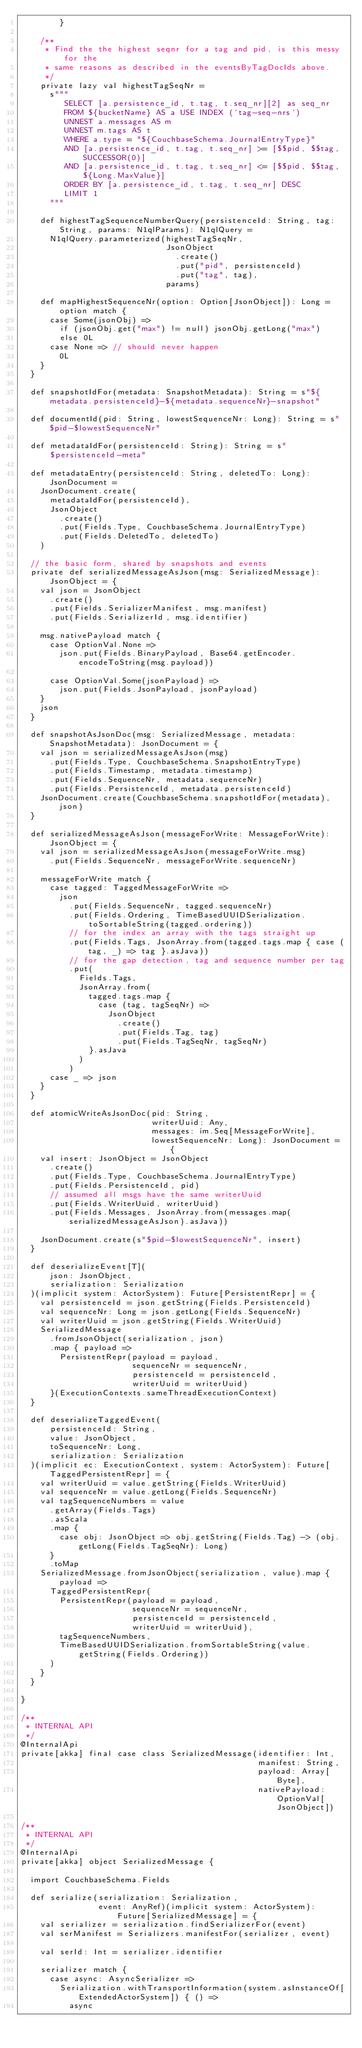<code> <loc_0><loc_0><loc_500><loc_500><_Scala_>        }

    /**
     * Find the the highest seqnr for a tag and pid, is this messy for the
     * same reasons as described in the eventsByTagDocIds above.
     */
    private lazy val highestTagSeqNr =
      s"""
         SELECT [a.persistence_id, t.tag, t.seq_nr][2] as seq_nr
         FROM ${bucketName} AS a USE INDEX (`tag-seq-nrs`)
         UNNEST a.messages AS m
         UNNEST m.tags AS t
         WHERE a.type = "${CouchbaseSchema.JournalEntryType}"
         AND [a.persistence_id, t.tag, t.seq_nr] >= [$$pid, $$tag, SUCCESSOR(0)]
         AND [a.persistence_id, t.tag, t.seq_nr] <= [$$pid, $$tag, ${Long.MaxValue}]
         ORDER BY [a.persistence_id, t.tag, t.seq_nr] DESC
         LIMIT 1
      """

    def highestTagSequenceNumberQuery(persistenceId: String, tag: String, params: N1qlParams): N1qlQuery =
      N1qlQuery.parameterized(highestTagSeqNr,
                              JsonObject
                                .create()
                                .put("pid", persistenceId)
                                .put("tag", tag),
                              params)

    def mapHighestSequenceNr(option: Option[JsonObject]): Long = option match {
      case Some(jsonObj) =>
        if (jsonObj.get("max") != null) jsonObj.getLong("max")
        else 0L
      case None => // should never happen
        0L
    }
  }

  def snapshotIdFor(metadata: SnapshotMetadata): String = s"${metadata.persistenceId}-${metadata.sequenceNr}-snapshot"

  def documentId(pid: String, lowestSequenceNr: Long): String = s"$pid-$lowestSequenceNr"

  def metadataIdFor(persistenceId: String): String = s"$persistenceId-meta"

  def metadataEntry(persistenceId: String, deletedTo: Long): JsonDocument =
    JsonDocument.create(
      metadataIdFor(persistenceId),
      JsonObject
        .create()
        .put(Fields.Type, CouchbaseSchema.JournalEntryType)
        .put(Fields.DeletedTo, deletedTo)
    )

  // the basic form, shared by snapshots and events
  private def serializedMessageAsJson(msg: SerializedMessage): JsonObject = {
    val json = JsonObject
      .create()
      .put(Fields.SerializerManifest, msg.manifest)
      .put(Fields.SerializerId, msg.identifier)

    msg.nativePayload match {
      case OptionVal.None =>
        json.put(Fields.BinaryPayload, Base64.getEncoder.encodeToString(msg.payload))

      case OptionVal.Some(jsonPayload) =>
        json.put(Fields.JsonPayload, jsonPayload)
    }
    json
  }

  def snapshotAsJsonDoc(msg: SerializedMessage, metadata: SnapshotMetadata): JsonDocument = {
    val json = serializedMessageAsJson(msg)
      .put(Fields.Type, CouchbaseSchema.SnapshotEntryType)
      .put(Fields.Timestamp, metadata.timestamp)
      .put(Fields.SequenceNr, metadata.sequenceNr)
      .put(Fields.PersistenceId, metadata.persistenceId)
    JsonDocument.create(CouchbaseSchema.snapshotIdFor(metadata), json)
  }

  def serializedMessageAsJson(messageForWrite: MessageForWrite): JsonObject = {
    val json = serializedMessageAsJson(messageForWrite.msg)
      .put(Fields.SequenceNr, messageForWrite.sequenceNr)

    messageForWrite match {
      case tagged: TaggedMessageForWrite =>
        json
          .put(Fields.SequenceNr, tagged.sequenceNr)
          .put(Fields.Ordering, TimeBasedUUIDSerialization.toSortableString(tagged.ordering))
          // for the index an array with the tags straight up
          .put(Fields.Tags, JsonArray.from(tagged.tags.map { case (tag, _) => tag }.asJava))
          // for the gap detection, tag and sequence number per tag
          .put(
            Fields.Tags,
            JsonArray.from(
              tagged.tags.map {
                case (tag, tagSeqNr) =>
                  JsonObject
                    .create()
                    .put(Fields.Tag, tag)
                    .put(Fields.TagSeqNr, tagSeqNr)
              }.asJava
            )
          )
      case _ => json
    }
  }

  def atomicWriteAsJsonDoc(pid: String,
                           writerUuid: Any,
                           messages: im.Seq[MessageForWrite],
                           lowestSequenceNr: Long): JsonDocument = {
    val insert: JsonObject = JsonObject
      .create()
      .put(Fields.Type, CouchbaseSchema.JournalEntryType)
      .put(Fields.PersistenceId, pid)
      // assumed all msgs have the same writerUuid
      .put(Fields.WriterUuid, writerUuid)
      .put(Fields.Messages, JsonArray.from(messages.map(serializedMessageAsJson).asJava))

    JsonDocument.create(s"$pid-$lowestSequenceNr", insert)
  }

  def deserializeEvent[T](
      json: JsonObject,
      serialization: Serialization
  )(implicit system: ActorSystem): Future[PersistentRepr] = {
    val persistenceId = json.getString(Fields.PersistenceId)
    val sequenceNr: Long = json.getLong(Fields.SequenceNr)
    val writerUuid = json.getString(Fields.WriterUuid)
    SerializedMessage
      .fromJsonObject(serialization, json)
      .map { payload =>
        PersistentRepr(payload = payload,
                       sequenceNr = sequenceNr,
                       persistenceId = persistenceId,
                       writerUuid = writerUuid)
      }(ExecutionContexts.sameThreadExecutionContext)
  }

  def deserializeTaggedEvent(
      persistenceId: String,
      value: JsonObject,
      toSequenceNr: Long,
      serialization: Serialization
  )(implicit ec: ExecutionContext, system: ActorSystem): Future[TaggedPersistentRepr] = {
    val writerUuid = value.getString(Fields.WriterUuid)
    val sequenceNr = value.getLong(Fields.SequenceNr)
    val tagSequenceNumbers = value
      .getArray(Fields.Tags)
      .asScala
      .map {
        case obj: JsonObject => obj.getString(Fields.Tag) -> (obj.getLong(Fields.TagSeqNr): Long)
      }
      .toMap
    SerializedMessage.fromJsonObject(serialization, value).map { payload =>
      TaggedPersistentRepr(
        PersistentRepr(payload = payload,
                       sequenceNr = sequenceNr,
                       persistenceId = persistenceId,
                       writerUuid = writerUuid),
        tagSequenceNumbers,
        TimeBasedUUIDSerialization.fromSortableString(value.getString(Fields.Ordering))
      )
    }
  }

}

/**
 * INTERNAL API
 */
@InternalApi
private[akka] final case class SerializedMessage(identifier: Int,
                                                 manifest: String,
                                                 payload: Array[Byte],
                                                 nativePayload: OptionVal[JsonObject])

/**
 * INTERNAL API
 */
@InternalApi
private[akka] object SerializedMessage {

  import CouchbaseSchema.Fields

  def serialize(serialization: Serialization,
                event: AnyRef)(implicit system: ActorSystem): Future[SerializedMessage] = {
    val serializer = serialization.findSerializerFor(event)
    val serManifest = Serializers.manifestFor(serializer, event)

    val serId: Int = serializer.identifier

    serializer match {
      case async: AsyncSerializer =>
        Serialization.withTransportInformation(system.asInstanceOf[ExtendedActorSystem]) { () =>
          async</code> 